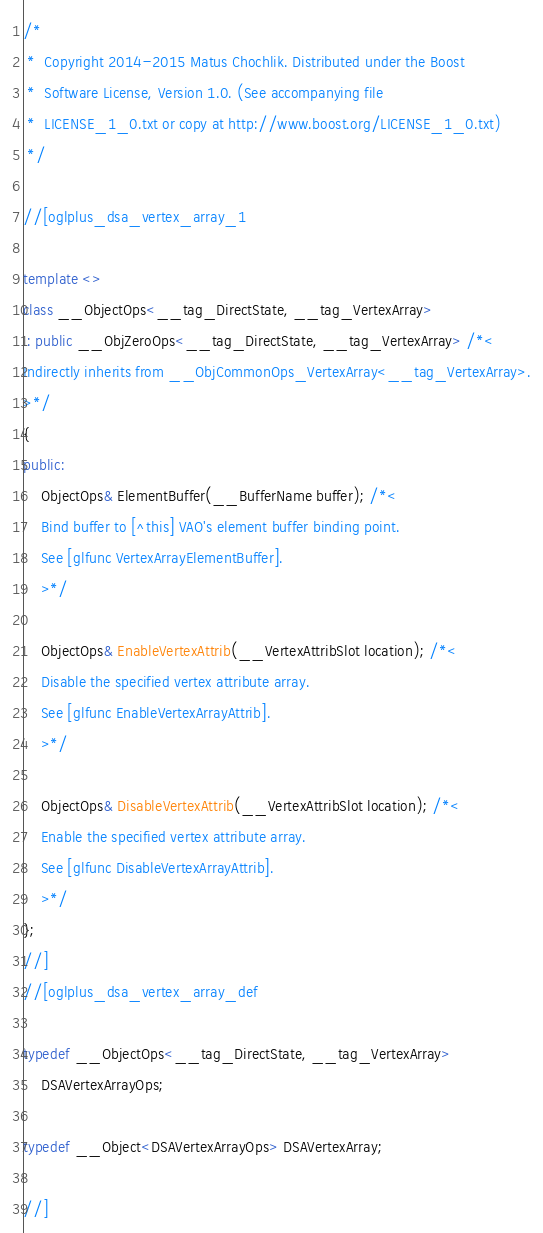<code> <loc_0><loc_0><loc_500><loc_500><_C++_>/*
 *  Copyright 2014-2015 Matus Chochlik. Distributed under the Boost
 *  Software License, Version 1.0. (See accompanying file
 *  LICENSE_1_0.txt or copy at http://www.boost.org/LICENSE_1_0.txt)
 */

//[oglplus_dsa_vertex_array_1

template <>
class __ObjectOps<__tag_DirectState, __tag_VertexArray>
 : public __ObjZeroOps<__tag_DirectState, __tag_VertexArray> /*<
Indirectly inherits from __ObjCommonOps_VertexArray<__tag_VertexArray>.
>*/
{
public:
	ObjectOps& ElementBuffer(__BufferName buffer); /*<
	Bind buffer to [^this] VAO's element buffer binding point.
	See [glfunc VertexArrayElementBuffer].
	>*/

	ObjectOps& EnableVertexAttrib(__VertexAttribSlot location); /*<
	Disable the specified vertex attribute array.
	See [glfunc EnableVertexArrayAttrib].
	>*/

	ObjectOps& DisableVertexAttrib(__VertexAttribSlot location); /*<
	Enable the specified vertex attribute array.
	See [glfunc DisableVertexArrayAttrib].
	>*/
};
//]
//[oglplus_dsa_vertex_array_def

typedef __ObjectOps<__tag_DirectState, __tag_VertexArray>
	DSAVertexArrayOps;

typedef __Object<DSAVertexArrayOps> DSAVertexArray;

//]

</code> 